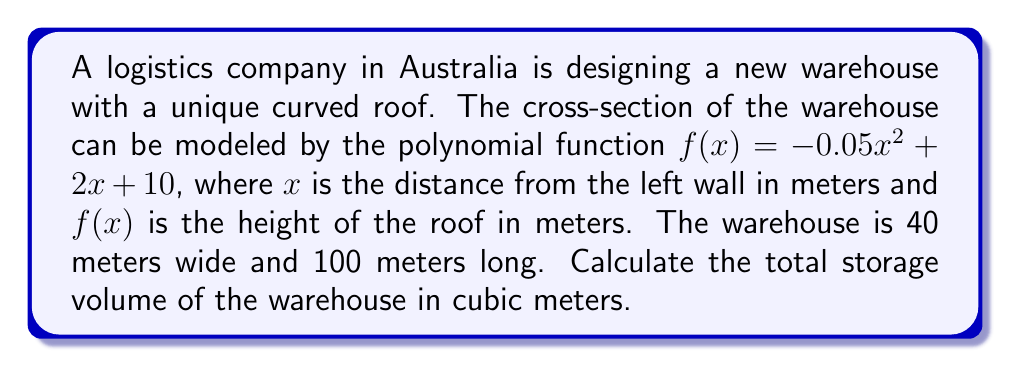Help me with this question. To calculate the storage volume, we need to find the area under the curve $f(x) = -0.05x^2 + 2x + 10$ from $x = 0$ to $x = 40$, and then multiply it by the length of the warehouse.

Step 1: Find the definite integral of $f(x)$ from 0 to 40.
$$\int_0^{40} (-0.05x^2 + 2x + 10) dx$$

Step 2: Integrate the function.
$$\left[-\frac{0.05x^3}{3} + x^2 + 10x\right]_0^{40}$$

Step 3: Evaluate the integral.
$$\left[-\frac{0.05(40^3)}{3} + 40^2 + 10(40)\right] - \left[-\frac{0.05(0^3)}{3} + 0^2 + 10(0)\right]$$
$$= [-1066.67 + 1600 + 400] - [0]$$
$$= 933.33$$

Step 4: The result of the integral gives us the area of the cross-section in square meters.

Step 5: Multiply the cross-sectional area by the length of the warehouse to get the volume.
$$\text{Volume} = 933.33 \times 100 = 93,333\text{ m}^3$$

Therefore, the total storage volume of the warehouse is 93,333 cubic meters.
Answer: 93,333 m³ 